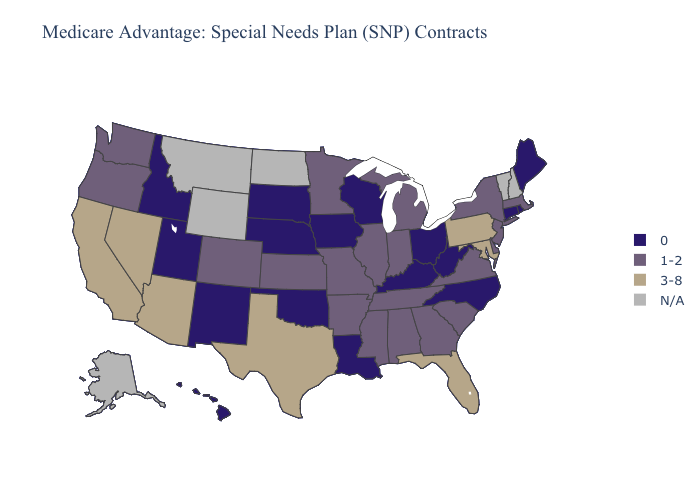What is the value of Indiana?
Answer briefly. 1-2. What is the value of California?
Quick response, please. 3-8. What is the highest value in states that border Indiana?
Concise answer only. 1-2. Name the states that have a value in the range 0?
Quick response, please. Connecticut, Hawaii, Iowa, Idaho, Kentucky, Louisiana, Maine, North Carolina, Nebraska, New Mexico, Ohio, Oklahoma, Rhode Island, South Dakota, Utah, Wisconsin, West Virginia. Does the first symbol in the legend represent the smallest category?
Give a very brief answer. Yes. What is the lowest value in the South?
Answer briefly. 0. What is the value of Montana?
Be succinct. N/A. Does the map have missing data?
Quick response, please. Yes. Name the states that have a value in the range 3-8?
Keep it brief. Arizona, California, Florida, Maryland, Nevada, Pennsylvania, Texas. Among the states that border Utah , which have the lowest value?
Give a very brief answer. Idaho, New Mexico. Name the states that have a value in the range 3-8?
Keep it brief. Arizona, California, Florida, Maryland, Nevada, Pennsylvania, Texas. What is the value of Wisconsin?
Keep it brief. 0. Which states hav the highest value in the South?
Be succinct. Florida, Maryland, Texas. 